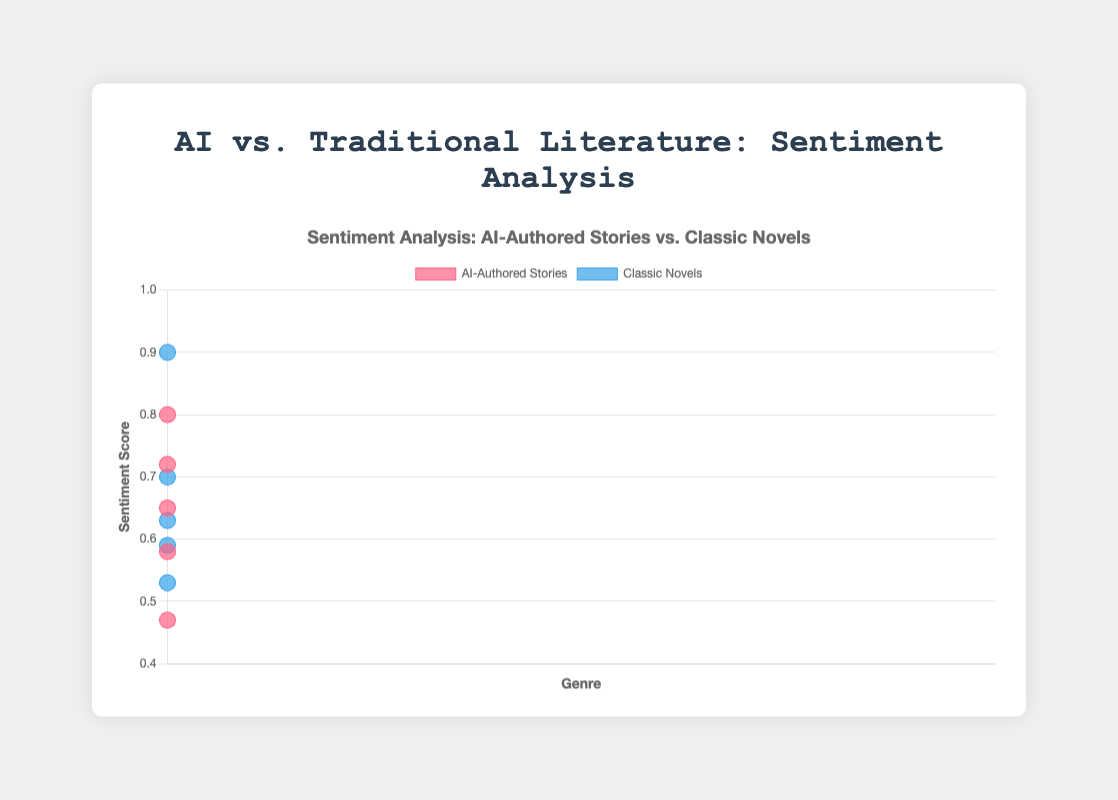What is the title of the figure? The title is displayed at the top of the figure. It reads "Sentiment Analysis: AI-Authored Stories vs. Classic Novels".
Answer: Sentiment Analysis: AI-Authored Stories vs. Classic Novels What are the axes titles in the figure? The x-axis is labeled "Genre" and the y-axis is labeled "Sentiment Score". These labels provide the context for the data points on each axis.
Answer: Genre (x-axis), Sentiment Score (y-axis) How many data points represent Romance genre stories? According to the legend and the data points on the figure, there are two data points in the Romance genre, one for AI-Authored Stories and one for Classic Novels.
Answer: 2 Which genre has the highest sentiment score for an AI-Authored story? From the scatter plot, the AI-Authored story with the highest sentiment score (0.80) corresponds to the Romance genre, represented by a dark pink point on the plot.
Answer: Romance What is the difference in sentiment score between the highest AI-authored story and the highest traditional work? The highest sentiment score for an AI-authored story is 0.80 (Romance), and the highest for a traditional work is 0.90 (Romance). The difference is 0.90 - 0.80 = 0.10.
Answer: 0.10 Which AI-authored genre has the lowest sentiment score? The AI-Authored story with the lowest sentiment score is in the Fantasy genre, having a sentiment score of 0.47.
Answer: Fantasy How do the sentiment scores of AI-authored Science Fiction stories compare to classic Science Fiction novels? The sentiment score for the AI-authored Science Fiction story is 0.65, while the classic Science Fiction novel has a sentiment score of 0.59. Thus, the AI-authored story's score is higher by 0.06.
Answer: The AI-authored story is higher by 0.06 Which genre shows the closest sentiment scores between AI-authored stories and traditional works? The Mystery genre shows the closest sentiment scores. The AI-authored story has 0.58, and the classic novel has 0.63, giving a difference of 0.05.
Answer: Mystery (difference of 0.05) Calculate the average sentiment score for AI-authored horror and traditional horror. The sentiment scores are 0.72 (AI-authored horror) and 0.70 (traditional horror). The average is (0.72 + 0.70) / 2 = 0.71.
Answer: 0.71 